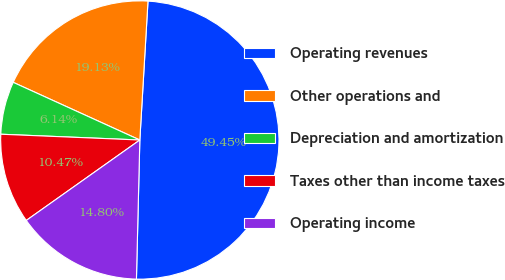Convert chart to OTSL. <chart><loc_0><loc_0><loc_500><loc_500><pie_chart><fcel>Operating revenues<fcel>Other operations and<fcel>Depreciation and amortization<fcel>Taxes other than income taxes<fcel>Operating income<nl><fcel>49.45%<fcel>19.13%<fcel>6.14%<fcel>10.47%<fcel>14.8%<nl></chart> 